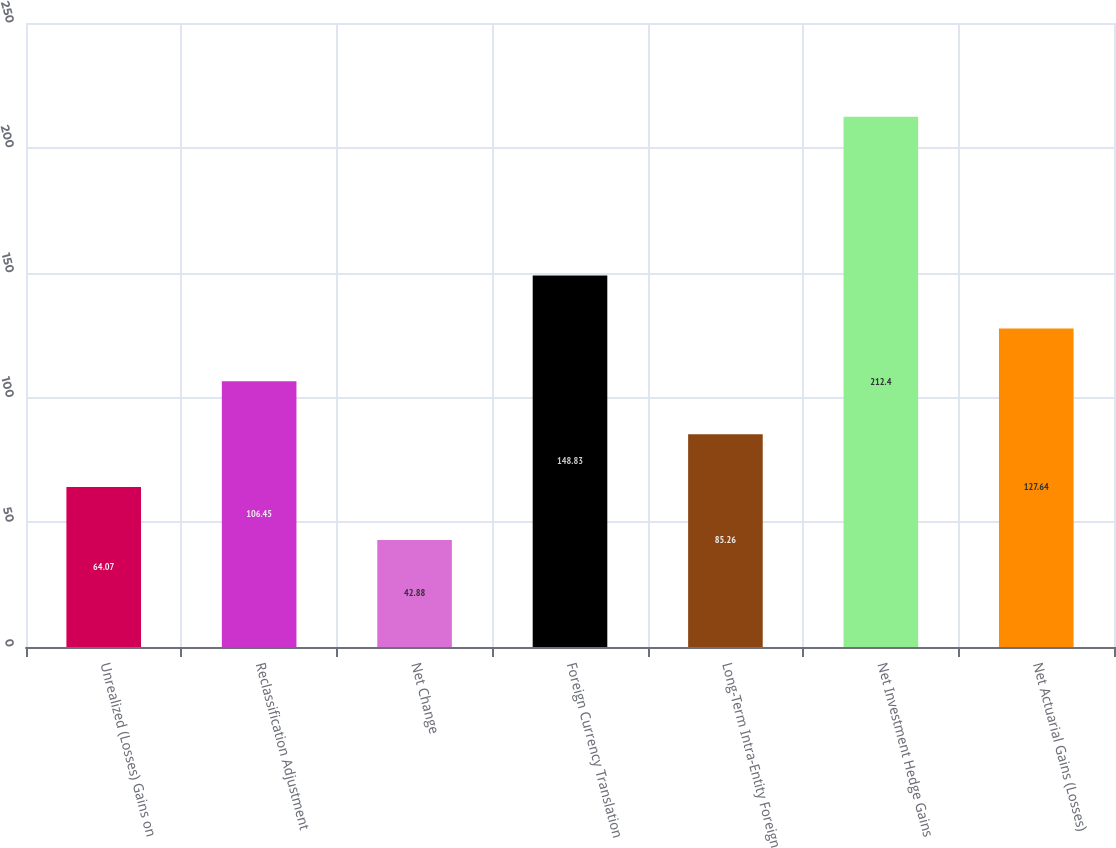Convert chart to OTSL. <chart><loc_0><loc_0><loc_500><loc_500><bar_chart><fcel>Unrealized (Losses) Gains on<fcel>Reclassification Adjustment<fcel>Net Change<fcel>Foreign Currency Translation<fcel>Long-Term Intra-Entity Foreign<fcel>Net Investment Hedge Gains<fcel>Net Actuarial Gains (Losses)<nl><fcel>64.07<fcel>106.45<fcel>42.88<fcel>148.83<fcel>85.26<fcel>212.4<fcel>127.64<nl></chart> 